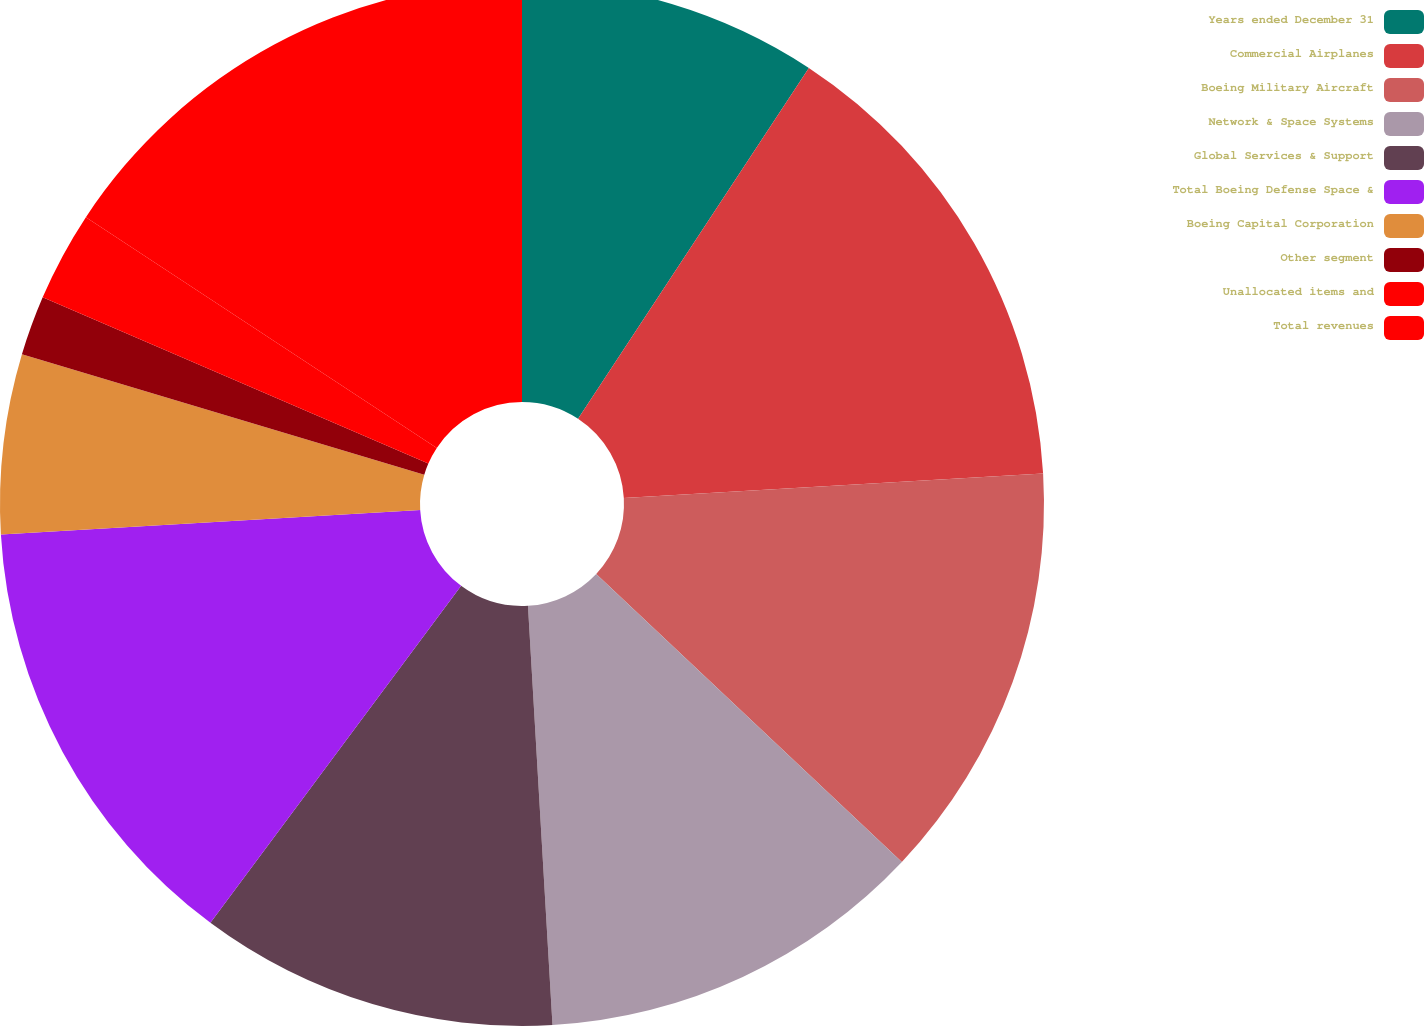Convert chart to OTSL. <chart><loc_0><loc_0><loc_500><loc_500><pie_chart><fcel>Years ended December 31<fcel>Commercial Airplanes<fcel>Boeing Military Aircraft<fcel>Network & Space Systems<fcel>Global Services & Support<fcel>Total Boeing Defense Space &<fcel>Boeing Capital Corporation<fcel>Other segment<fcel>Unallocated items and<fcel>Total revenues<nl><fcel>9.26%<fcel>14.81%<fcel>12.96%<fcel>12.04%<fcel>11.11%<fcel>13.89%<fcel>5.56%<fcel>1.85%<fcel>2.78%<fcel>15.74%<nl></chart> 